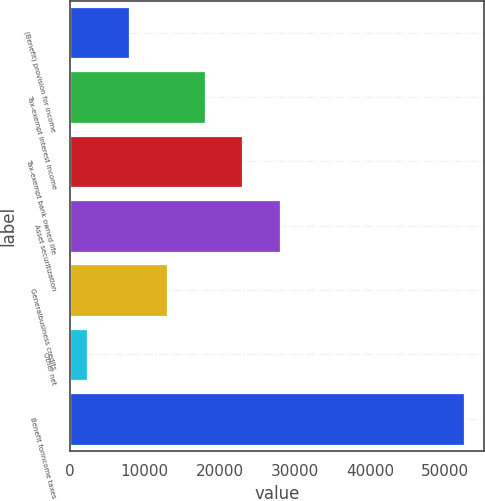<chart> <loc_0><loc_0><loc_500><loc_500><bar_chart><fcel>(Benefit) provision for income<fcel>Tax-exempt interest income<fcel>Tax-exempt bank owned life<fcel>Asset securitization<fcel>Generalbusiness credits<fcel>Other net<fcel>Benefit forincome taxes<nl><fcel>7925<fcel>17964.2<fcel>22983.8<fcel>28003.4<fcel>12944.6<fcel>2330<fcel>52526<nl></chart> 